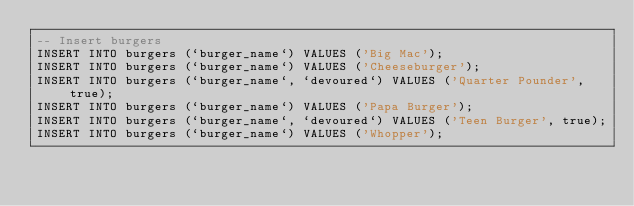<code> <loc_0><loc_0><loc_500><loc_500><_SQL_>-- Insert burgers
INSERT INTO burgers (`burger_name`) VALUES ('Big Mac');
INSERT INTO burgers (`burger_name`) VALUES ('Cheeseburger');
INSERT INTO burgers (`burger_name`, `devoured`) VALUES ('Quarter Pounder', true);
INSERT INTO burgers (`burger_name`) VALUES ('Papa Burger');
INSERT INTO burgers (`burger_name`, `devoured`) VALUES ('Teen Burger', true);
INSERT INTO burgers (`burger_name`) VALUES ('Whopper');</code> 